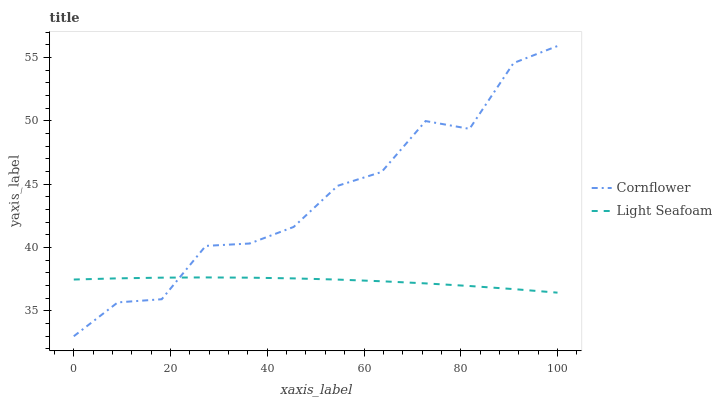Does Light Seafoam have the minimum area under the curve?
Answer yes or no. Yes. Does Cornflower have the maximum area under the curve?
Answer yes or no. Yes. Does Light Seafoam have the maximum area under the curve?
Answer yes or no. No. Is Light Seafoam the smoothest?
Answer yes or no. Yes. Is Cornflower the roughest?
Answer yes or no. Yes. Is Light Seafoam the roughest?
Answer yes or no. No. Does Cornflower have the lowest value?
Answer yes or no. Yes. Does Light Seafoam have the lowest value?
Answer yes or no. No. Does Cornflower have the highest value?
Answer yes or no. Yes. Does Light Seafoam have the highest value?
Answer yes or no. No. Does Cornflower intersect Light Seafoam?
Answer yes or no. Yes. Is Cornflower less than Light Seafoam?
Answer yes or no. No. Is Cornflower greater than Light Seafoam?
Answer yes or no. No. 